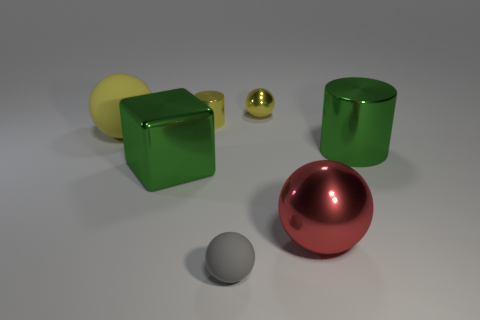There is a metal cylinder that is the same color as the large cube; what is its size?
Provide a succinct answer. Large. Does the small shiny ball have the same color as the small cylinder?
Ensure brevity in your answer.  Yes. There is a large thing that is both behind the shiny cube and to the left of the large green metallic cylinder; what shape is it?
Offer a very short reply. Sphere. How many other things are the same color as the big shiny ball?
Offer a terse response. 0. What is the shape of the big yellow rubber thing?
Provide a short and direct response. Sphere. What is the color of the cylinder to the right of the matte sphere that is on the right side of the large metallic cube?
Your answer should be very brief. Green. Is the color of the large rubber ball the same as the large ball in front of the big green metallic cylinder?
Your response must be concise. No. What material is the large object that is both behind the large green shiny cube and left of the small yellow cylinder?
Make the answer very short. Rubber. Are there any red shiny spheres of the same size as the yellow matte object?
Keep it short and to the point. Yes. What is the material of the green cylinder that is the same size as the red metallic thing?
Offer a very short reply. Metal. 